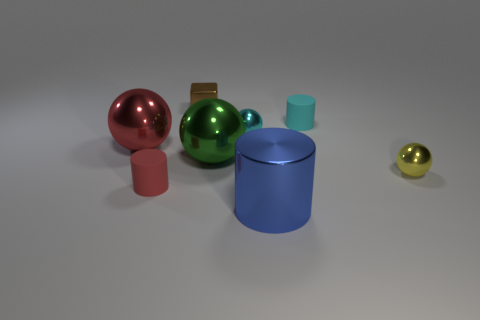Add 1 tiny yellow blocks. How many objects exist? 9 Subtract all cubes. How many objects are left? 7 Subtract all cyan matte cylinders. Subtract all small brown objects. How many objects are left? 6 Add 3 tiny cylinders. How many tiny cylinders are left? 5 Add 8 yellow metal spheres. How many yellow metal spheres exist? 9 Subtract 0 gray cylinders. How many objects are left? 8 